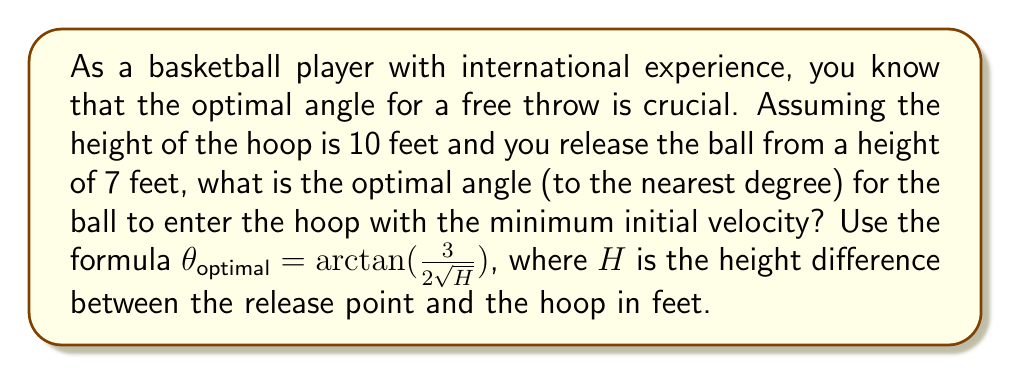Solve this math problem. Let's approach this step-by-step:

1) First, we need to determine the height difference ($H$) between the release point and the hoop:
   $H = \text{Hoop height} - \text{Release height}$
   $H = 10 \text{ feet} - 7 \text{ feet} = 3 \text{ feet}$

2) Now we can substitute this into the given formula:
   $\theta_{optimal} = \arctan(\frac{3}{2\sqrt{H}})$

3) Substituting $H = 3$:
   $\theta_{optimal} = \arctan(\frac{3}{2\sqrt{3}})$

4) Simplify inside the parentheses:
   $\theta_{optimal} = \arctan(\frac{3}{2 \cdot 1.732})$
   $\theta_{optimal} = \arctan(0.866)$

5) Calculate the arctangent:
   $\theta_{optimal} \approx 40.893°$

6) Rounding to the nearest degree:
   $\theta_{optimal} \approx 41°$

This angle of approximately 41° will allow the ball to enter the hoop with the minimum initial velocity, making it the optimal angle for your free throw.
Answer: 41° 